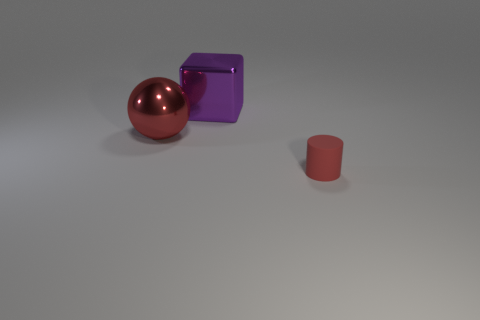Add 2 red things. How many objects exist? 5 Subtract all cylinders. How many objects are left? 2 Add 3 small red matte cylinders. How many small red matte cylinders are left? 4 Add 2 big things. How many big things exist? 4 Subtract 0 brown blocks. How many objects are left? 3 Subtract all large brown cylinders. Subtract all spheres. How many objects are left? 2 